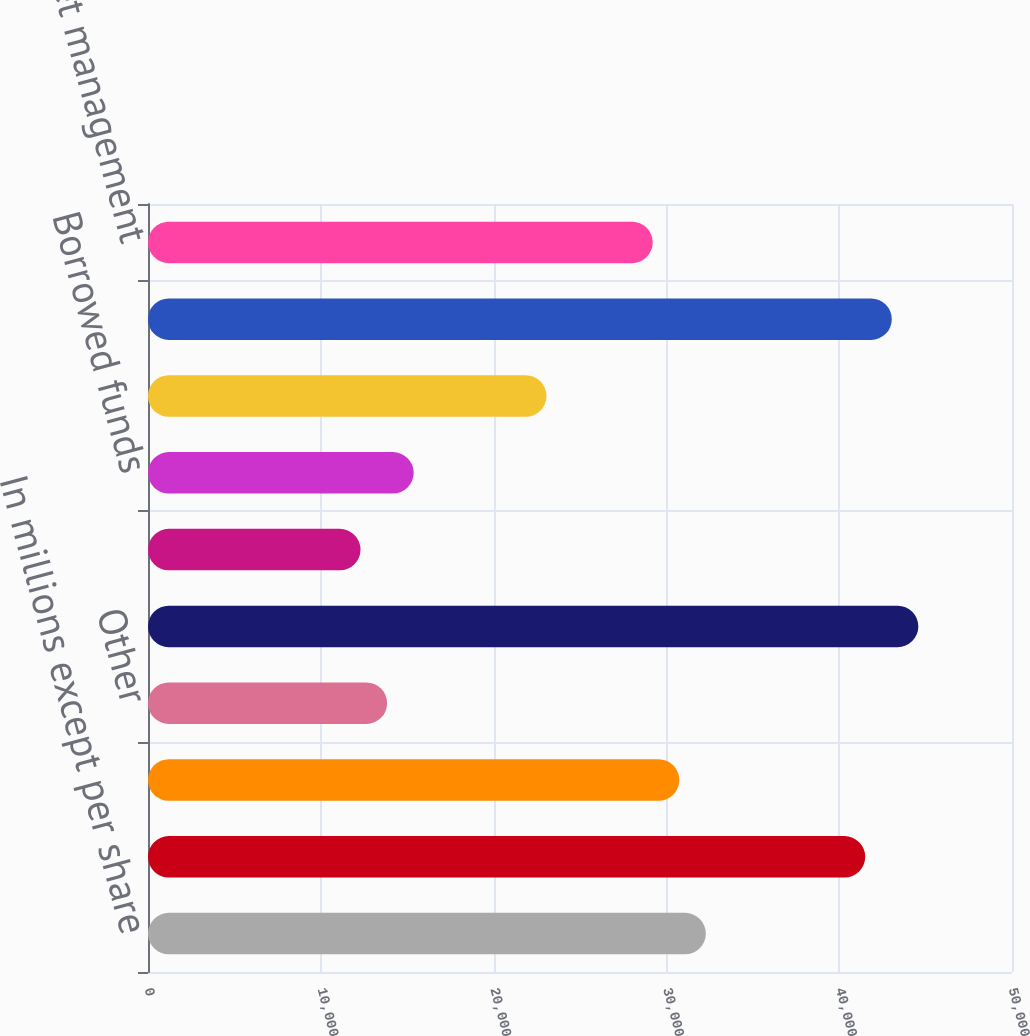Convert chart to OTSL. <chart><loc_0><loc_0><loc_500><loc_500><bar_chart><fcel>In millions except per share<fcel>Loans<fcel>Investment securities<fcel>Other<fcel>Total interest income<fcel>Deposits<fcel>Borrowed funds<fcel>Total interest expense<fcel>Net interest income<fcel>Asset management<nl><fcel>32283.1<fcel>41505.7<fcel>30746<fcel>13837.9<fcel>44579.9<fcel>12300.8<fcel>15375<fcel>23060.5<fcel>43042.8<fcel>29208.9<nl></chart> 